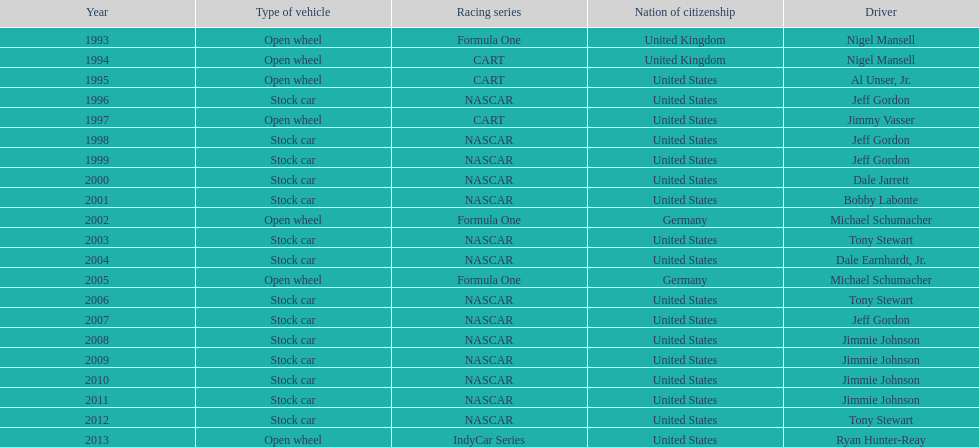Out of these drivers: nigel mansell, al unser, jr., michael schumacher, and jeff gordon, all but one has more than one espy award. who only has one espy award? Al Unser, Jr. 